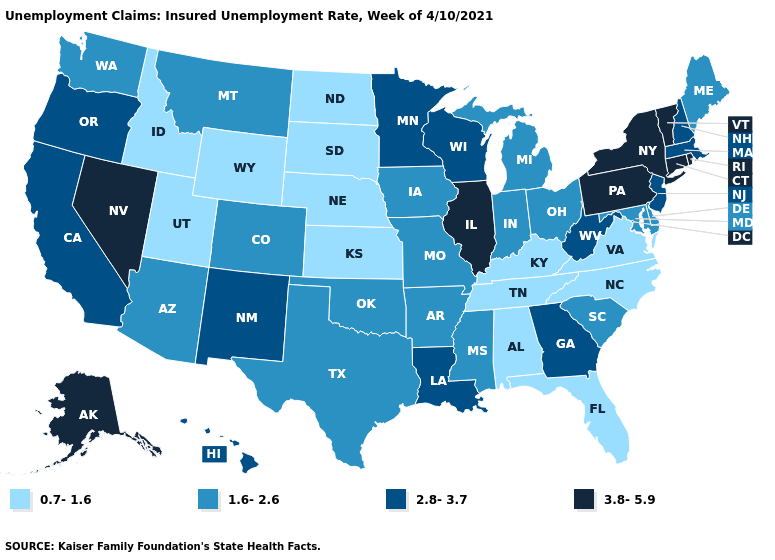Does Nevada have a higher value than Wisconsin?
Keep it brief. Yes. Among the states that border New York , does Connecticut have the highest value?
Answer briefly. Yes. Name the states that have a value in the range 0.7-1.6?
Be succinct. Alabama, Florida, Idaho, Kansas, Kentucky, Nebraska, North Carolina, North Dakota, South Dakota, Tennessee, Utah, Virginia, Wyoming. What is the value of Georgia?
Quick response, please. 2.8-3.7. Which states have the highest value in the USA?
Give a very brief answer. Alaska, Connecticut, Illinois, Nevada, New York, Pennsylvania, Rhode Island, Vermont. What is the value of North Dakota?
Concise answer only. 0.7-1.6. Which states have the lowest value in the Northeast?
Concise answer only. Maine. Which states hav the highest value in the MidWest?
Give a very brief answer. Illinois. Does the map have missing data?
Be succinct. No. Among the states that border Rhode Island , which have the highest value?
Be succinct. Connecticut. Name the states that have a value in the range 1.6-2.6?
Be succinct. Arizona, Arkansas, Colorado, Delaware, Indiana, Iowa, Maine, Maryland, Michigan, Mississippi, Missouri, Montana, Ohio, Oklahoma, South Carolina, Texas, Washington. Which states have the lowest value in the USA?
Short answer required. Alabama, Florida, Idaho, Kansas, Kentucky, Nebraska, North Carolina, North Dakota, South Dakota, Tennessee, Utah, Virginia, Wyoming. Name the states that have a value in the range 1.6-2.6?
Answer briefly. Arizona, Arkansas, Colorado, Delaware, Indiana, Iowa, Maine, Maryland, Michigan, Mississippi, Missouri, Montana, Ohio, Oklahoma, South Carolina, Texas, Washington. Name the states that have a value in the range 0.7-1.6?
Concise answer only. Alabama, Florida, Idaho, Kansas, Kentucky, Nebraska, North Carolina, North Dakota, South Dakota, Tennessee, Utah, Virginia, Wyoming. 